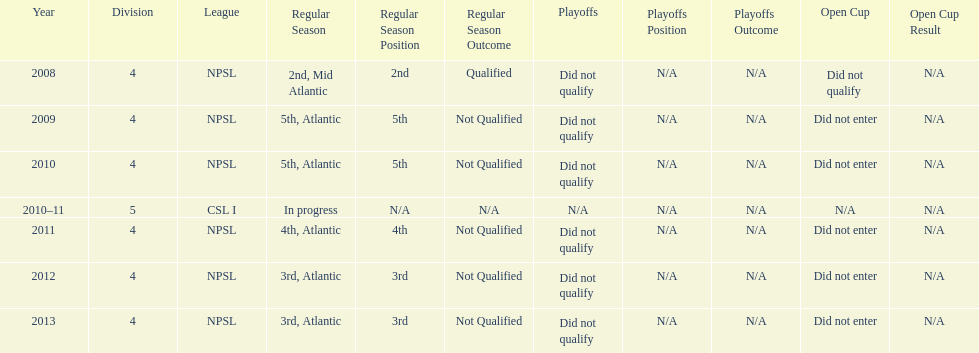Could you parse the entire table as a dict? {'header': ['Year', 'Division', 'League', 'Regular Season', 'Regular Season Position', 'Regular Season Outcome', 'Playoffs', 'Playoffs Position', 'Playoffs Outcome', 'Open Cup', 'Open Cup Result'], 'rows': [['2008', '4', 'NPSL', '2nd, Mid Atlantic', '2nd', 'Qualified', 'Did not qualify', 'N/A', 'N/A', 'Did not qualify', 'N/A'], ['2009', '4', 'NPSL', '5th, Atlantic', '5th', 'Not Qualified', 'Did not qualify', 'N/A', 'N/A', 'Did not enter', 'N/A'], ['2010', '4', 'NPSL', '5th, Atlantic', '5th', 'Not Qualified', 'Did not qualify', 'N/A', 'N/A', 'Did not enter', 'N/A'], ['2010–11', '5', 'CSL I', 'In progress', 'N/A', 'N/A', 'N/A', 'N/A', 'N/A', 'N/A', 'N/A'], ['2011', '4', 'NPSL', '4th, Atlantic', '4th', 'Not Qualified', 'Did not qualify', 'N/A', 'N/A', 'Did not enter', 'N/A'], ['2012', '4', 'NPSL', '3rd, Atlantic', '3rd', 'Not Qualified', 'Did not qualify', 'N/A', 'N/A', 'Did not enter', 'N/A'], ['2013', '4', 'NPSL', '3rd, Atlantic', '3rd', 'Not Qualified', 'Did not qualify', 'N/A', 'N/A', 'Did not enter', 'N/A']]} When was the final year they achieved a 5th place position? 2010. 